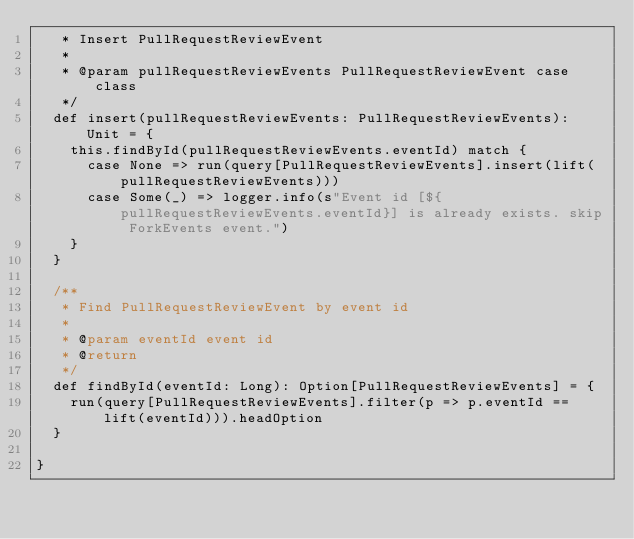<code> <loc_0><loc_0><loc_500><loc_500><_Scala_>   * Insert PullRequestReviewEvent
   *
   * @param pullRequestReviewEvents PullRequestReviewEvent case class
   */
  def insert(pullRequestReviewEvents: PullRequestReviewEvents): Unit = {
    this.findById(pullRequestReviewEvents.eventId) match {
      case None => run(query[PullRequestReviewEvents].insert(lift(pullRequestReviewEvents)))
      case Some(_) => logger.info(s"Event id [${pullRequestReviewEvents.eventId}] is already exists. skip ForkEvents event.")
    }
  }

  /**
   * Find PullRequestReviewEvent by event id
   *
   * @param eventId event id
   * @return
   */
  def findById(eventId: Long): Option[PullRequestReviewEvents] = {
    run(query[PullRequestReviewEvents].filter(p => p.eventId == lift(eventId))).headOption
  }

}
</code> 